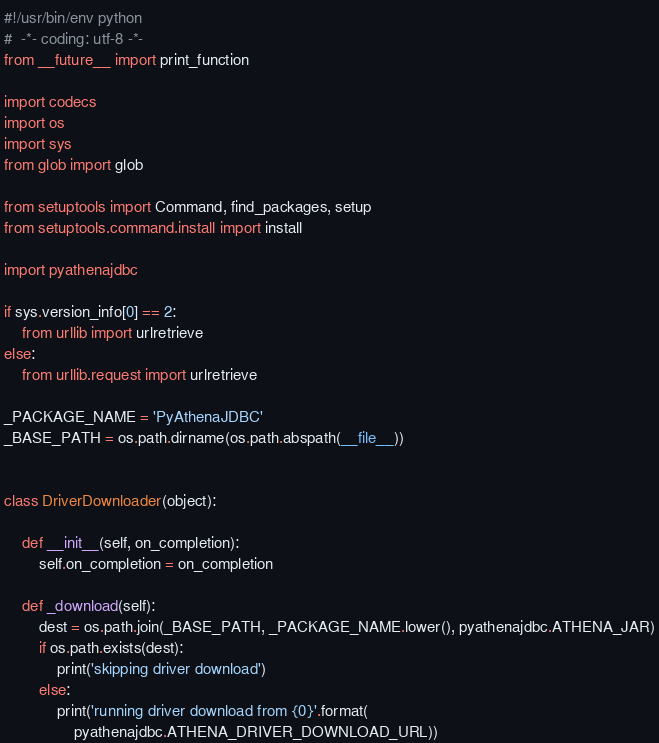<code> <loc_0><loc_0><loc_500><loc_500><_Python_>#!/usr/bin/env python
#  -*- coding: utf-8 -*-
from __future__ import print_function

import codecs
import os
import sys
from glob import glob

from setuptools import Command, find_packages, setup
from setuptools.command.install import install

import pyathenajdbc

if sys.version_info[0] == 2:
    from urllib import urlretrieve
else:
    from urllib.request import urlretrieve

_PACKAGE_NAME = 'PyAthenaJDBC'
_BASE_PATH = os.path.dirname(os.path.abspath(__file__))


class DriverDownloader(object):

    def __init__(self, on_completion):
        self.on_completion = on_completion

    def _download(self):
        dest = os.path.join(_BASE_PATH, _PACKAGE_NAME.lower(), pyathenajdbc.ATHENA_JAR)
        if os.path.exists(dest):
            print('skipping driver download')
        else:
            print('running driver download from {0}'.format(
                pyathenajdbc.ATHENA_DRIVER_DOWNLOAD_URL))</code> 